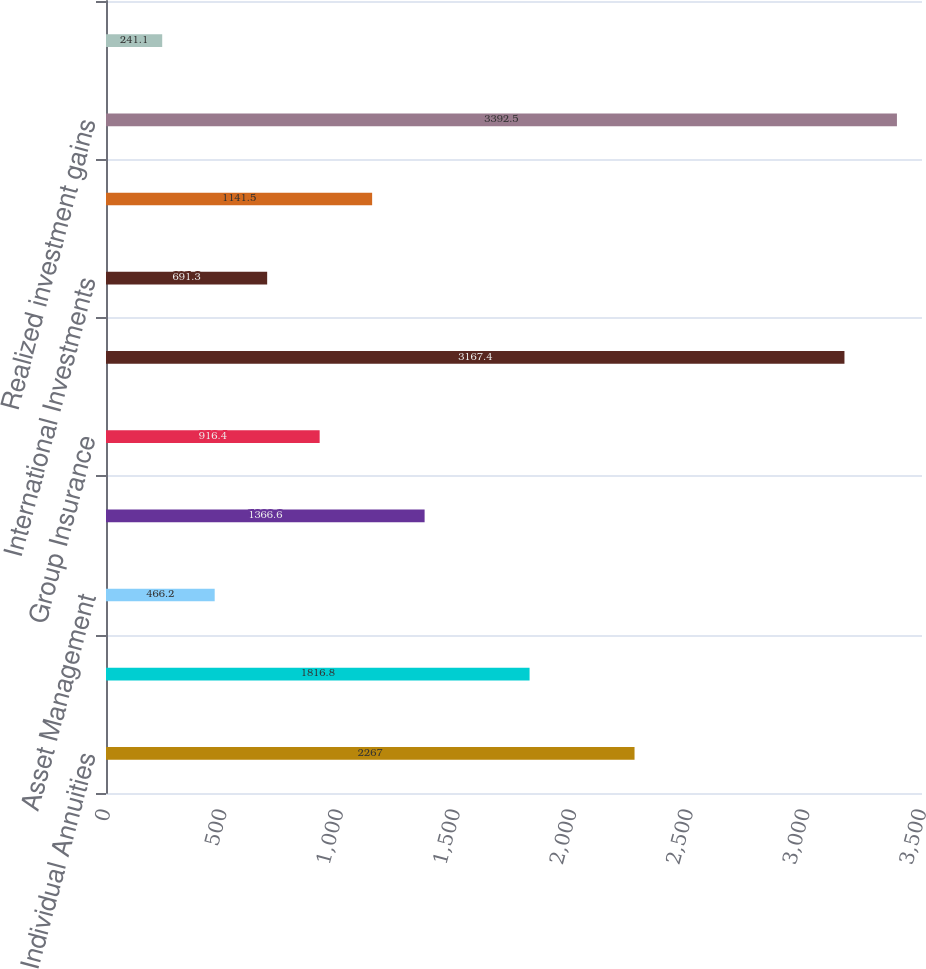Convert chart. <chart><loc_0><loc_0><loc_500><loc_500><bar_chart><fcel>Individual Annuities<fcel>Retirement<fcel>Asset Management<fcel>Individual Life<fcel>Group Insurance<fcel>International Insurance<fcel>International Investments<fcel>Corporate and Other<fcel>Realized investment gains<fcel>Charges related to realized<nl><fcel>2267<fcel>1816.8<fcel>466.2<fcel>1366.6<fcel>916.4<fcel>3167.4<fcel>691.3<fcel>1141.5<fcel>3392.5<fcel>241.1<nl></chart> 